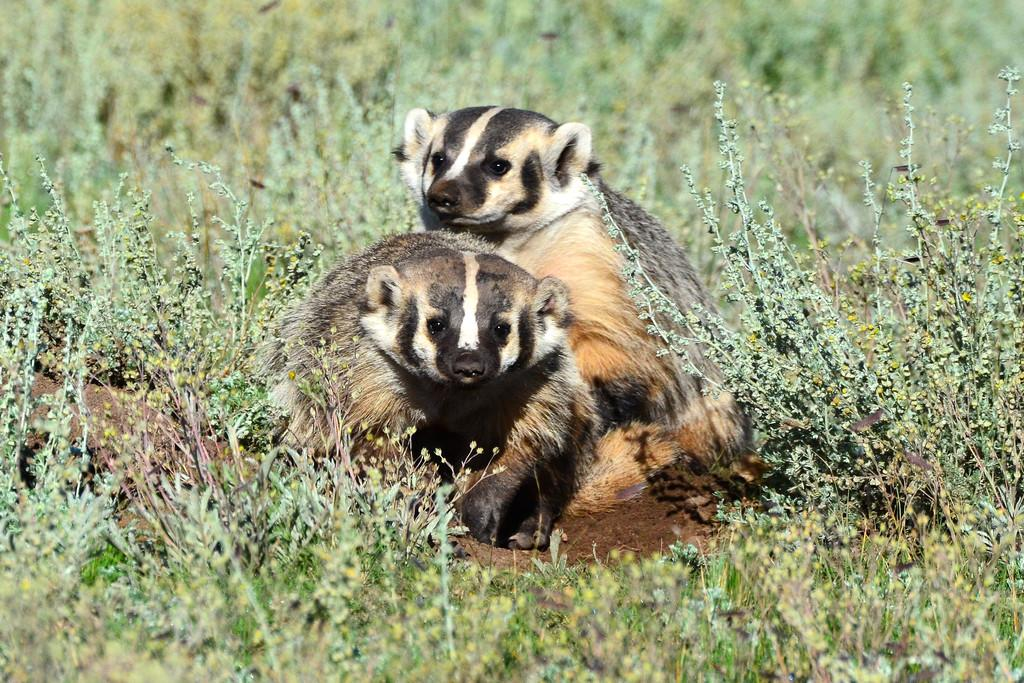What animals are in the front of the image? There are two badgers in the front of the image. What can be seen at the bottom of the image? There are plants at the bottom of the image. What action is the crook taking in the image? There is no crook present in the image, so no action can be attributed to a crook. 